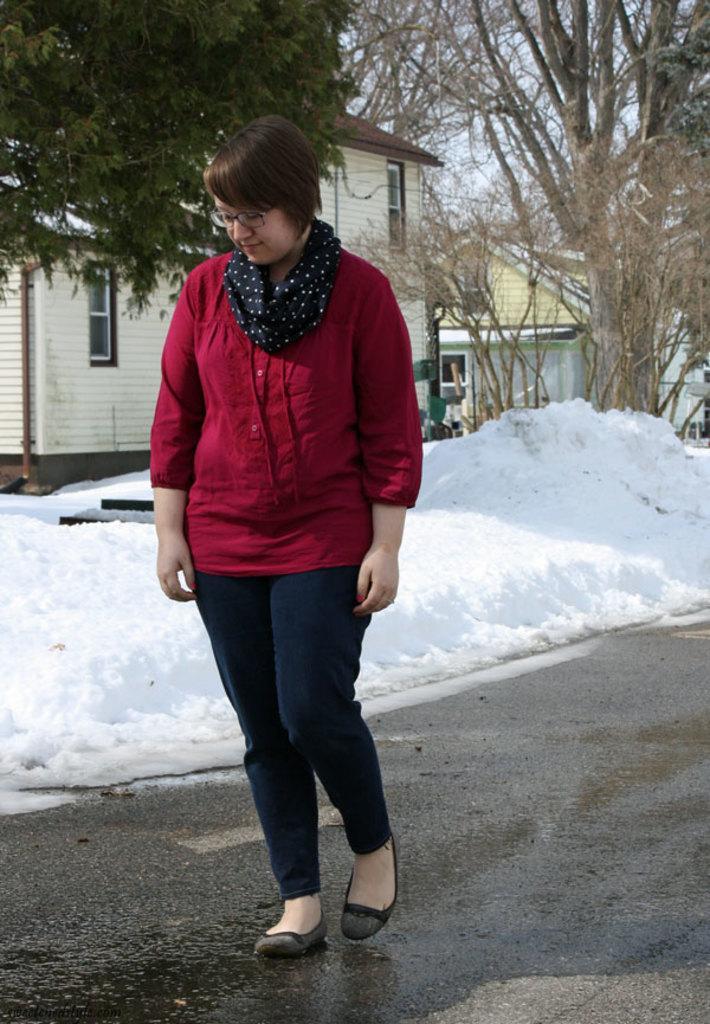Please provide a concise description of this image. In this image I can see a woman is standing. The woman is wearing a scarf, red color top and pant. In the background I can see houses, trees, snow and the sky. 